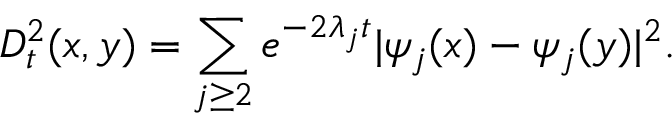Convert formula to latex. <formula><loc_0><loc_0><loc_500><loc_500>D _ { t } ^ { 2 } ( x , y ) = \sum _ { j \geq 2 } e ^ { - 2 \lambda _ { j } t } | \psi _ { j } ( x ) - \psi _ { j } ( y ) | ^ { 2 } .</formula> 